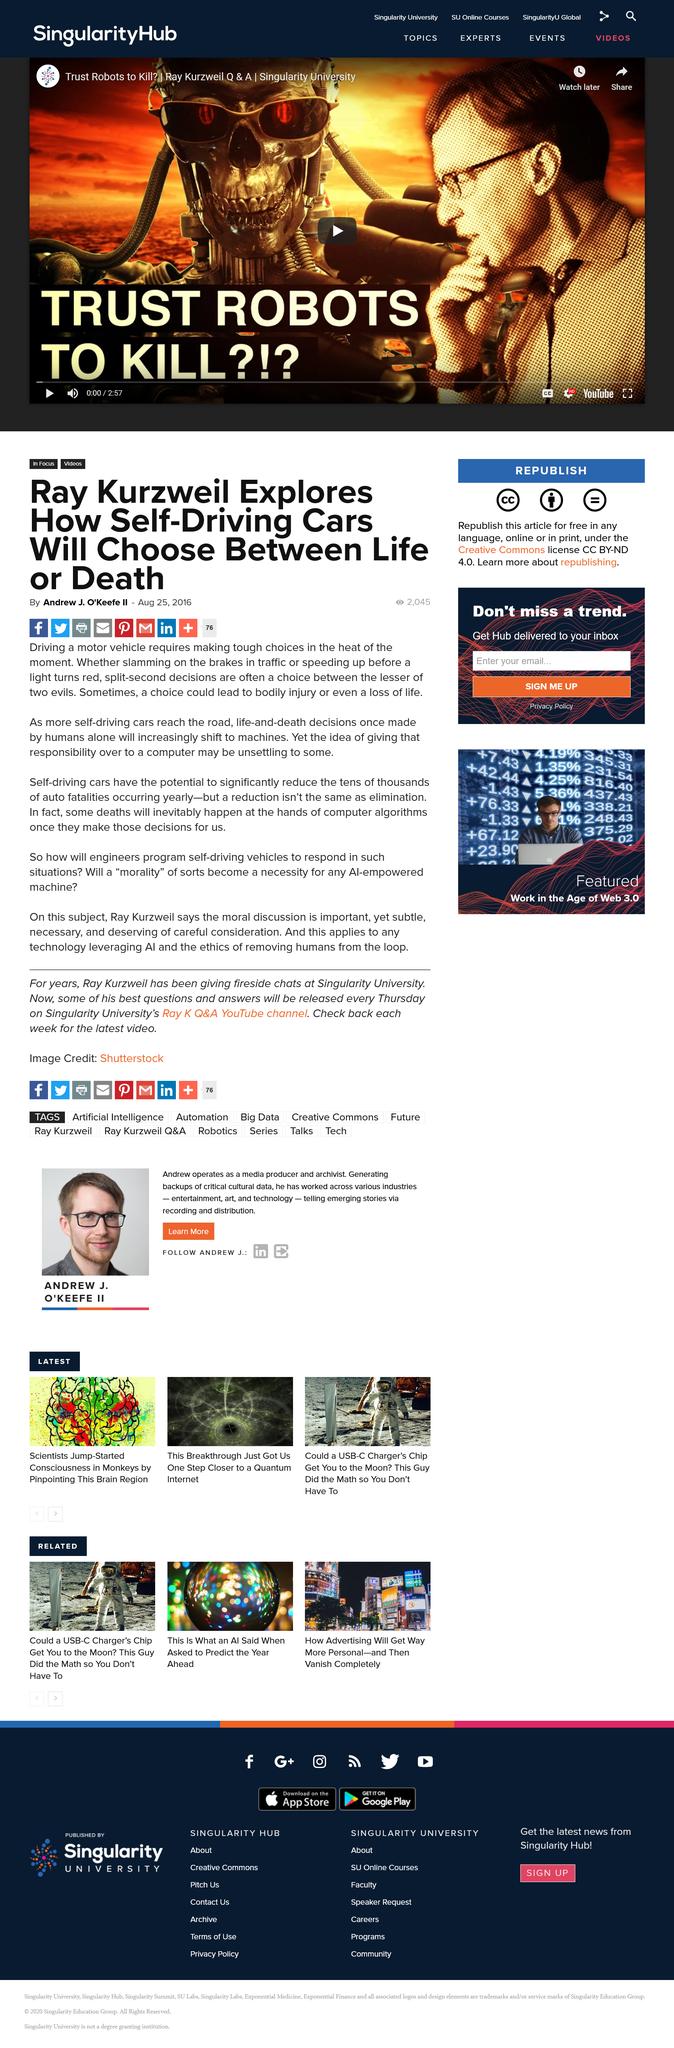Point out several critical features in this image. Driving with sudden and reckless actions, such as lamming on the brakes in traffic, speeding up before a light turns red, and making split-second decisions, can result in serious consequences, including physical harm or even loss of life. The invention of self-driving cars has the potential to significantly reduce the tens of thousands of fatalities that occur annually due to automobile accidents. Andrew J. O'Keefe II was the writer of this article. 